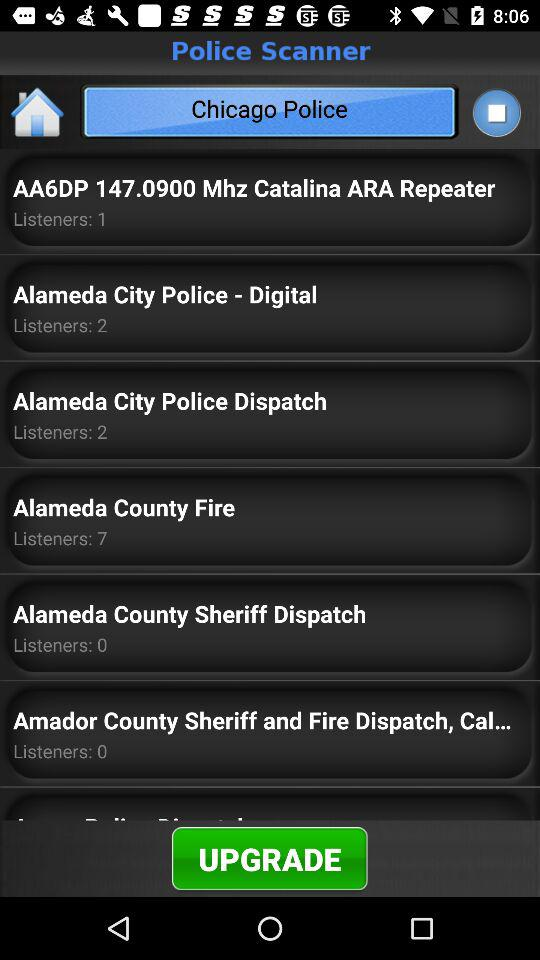How many listeners are in Alameda County fire? There are 7 listeners. 